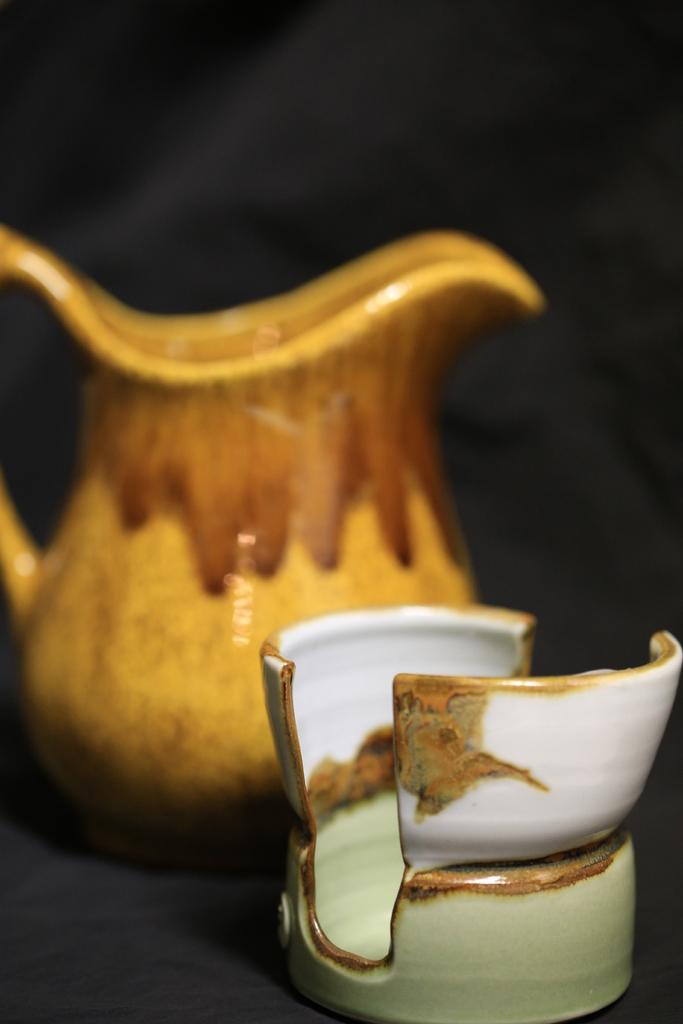What is the main object in the image? There is a cup in the image. What is the color of the surface the cup is on? The cup is on a black surface. How would you describe the background of the image? The background of the image is dark and slightly blurred. What other object can be seen on the surface in the image? There is a jar on the surface in the image. Can you see the tail of the animal in the image? There is no animal present in the image, so there is no tail to be seen. 